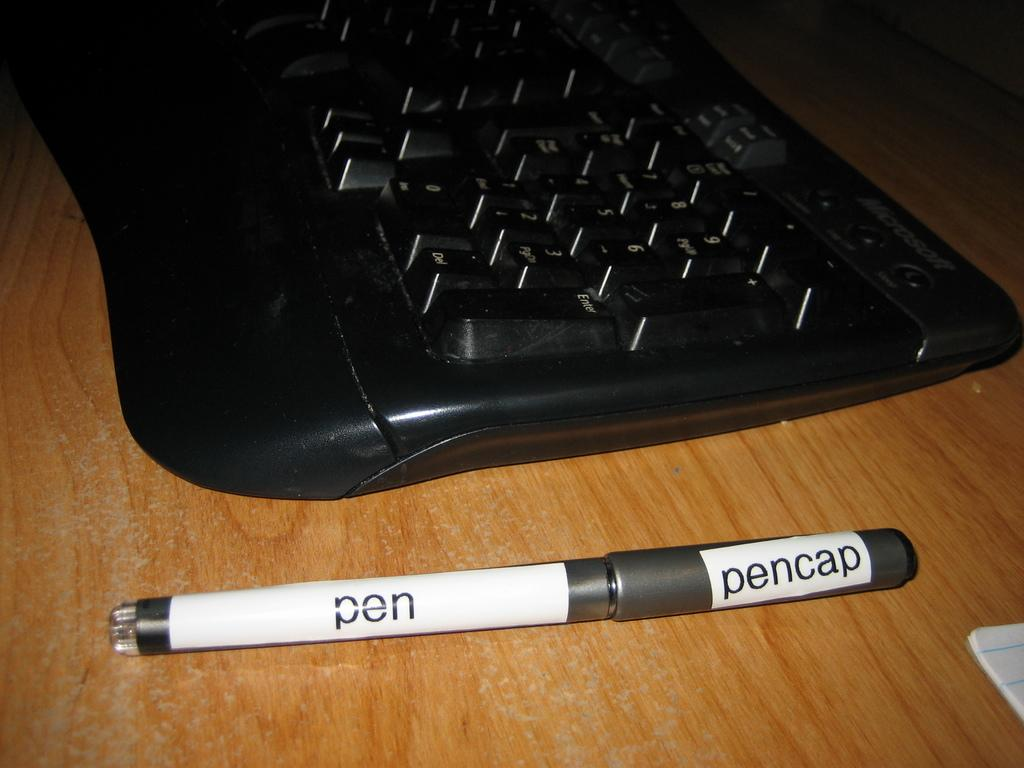<image>
Summarize the visual content of the image. A black keyboards sits behind a pen that has white labels on it that say pen and pencap. 